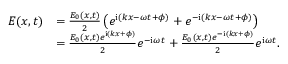<formula> <loc_0><loc_0><loc_500><loc_500>\begin{array} { r l } { E ( x , t ) } & { = \frac { E _ { 0 } ( x , t ) } { 2 } \left ( e ^ { { i } ( k x - \omega t + \phi ) } + e ^ { - { i } ( k x - \omega t + \phi ) } \right ) } \\ & { = \frac { E _ { 0 } ( x , t ) e ^ { { i } ( k x + \phi ) } } { 2 } e ^ { - { i } \omega t } + \frac { E _ { 0 } ( x , t ) e ^ { - { i } ( k x + \phi ) } } { 2 } e ^ { { i } \omega t } . } \end{array}</formula> 